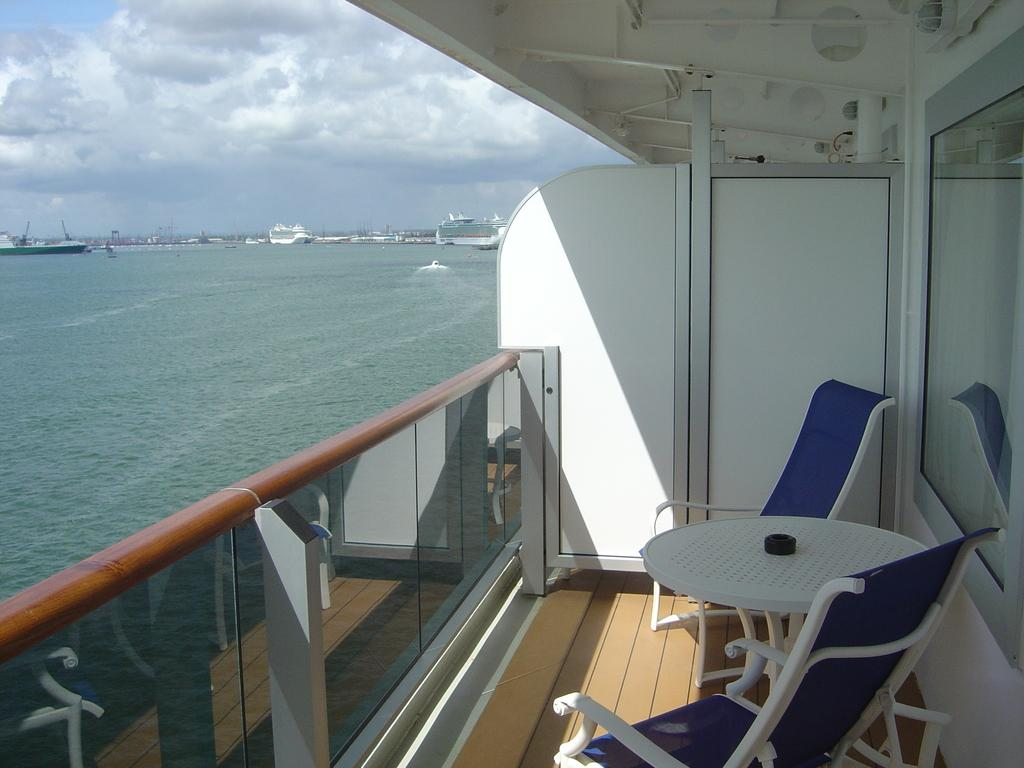What type of furniture is located on the right side of the image? There is a table and chairs on the right side of the image. Where are the table and chairs situated? The table and chairs are on a ship. What can be seen in the background of the image? Ships, water, sky, and clouds are visible in the background of the image. What type of chalk is being used to draw on the ship's deck in the image? There is no chalk present in the image, and no drawing activity is depicted. What does the image smell like? The image is a visual representation and does not have a smell. 